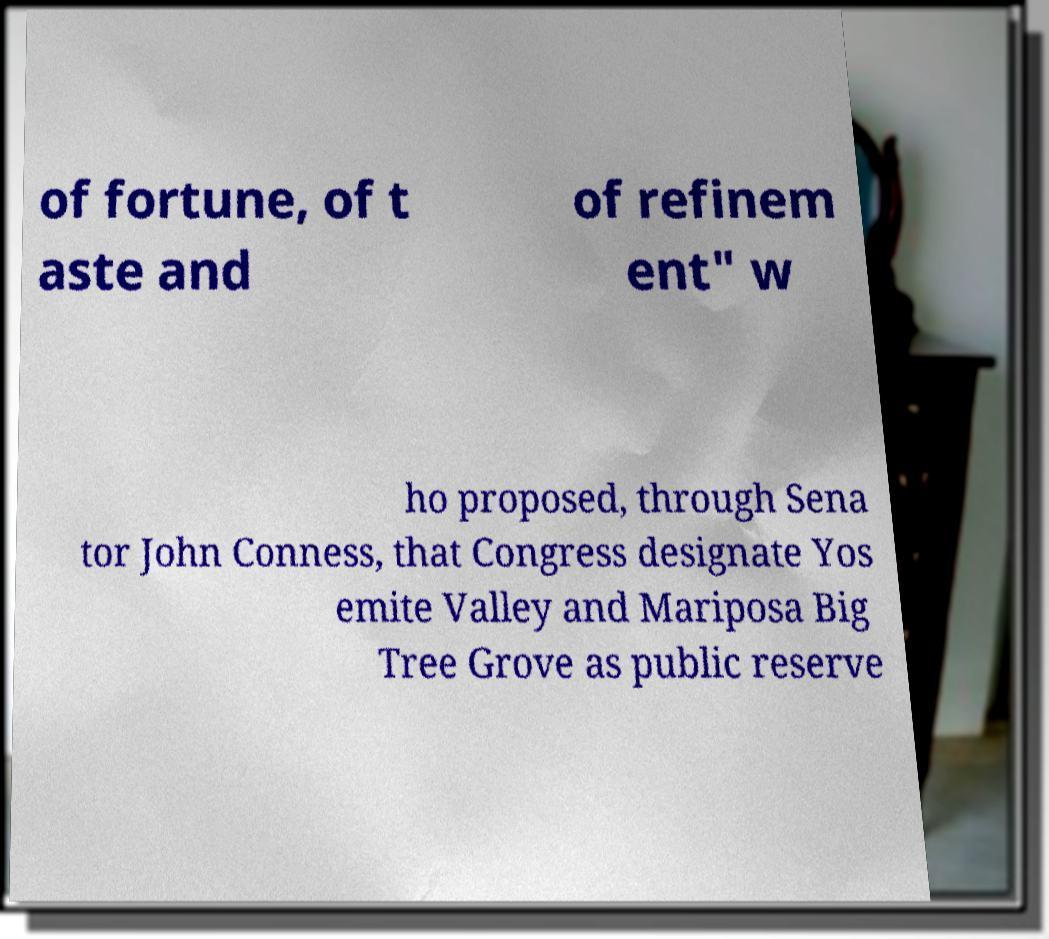Could you assist in decoding the text presented in this image and type it out clearly? of fortune, of t aste and of refinem ent" w ho proposed, through Sena tor John Conness, that Congress designate Yos emite Valley and Mariposa Big Tree Grove as public reserve 